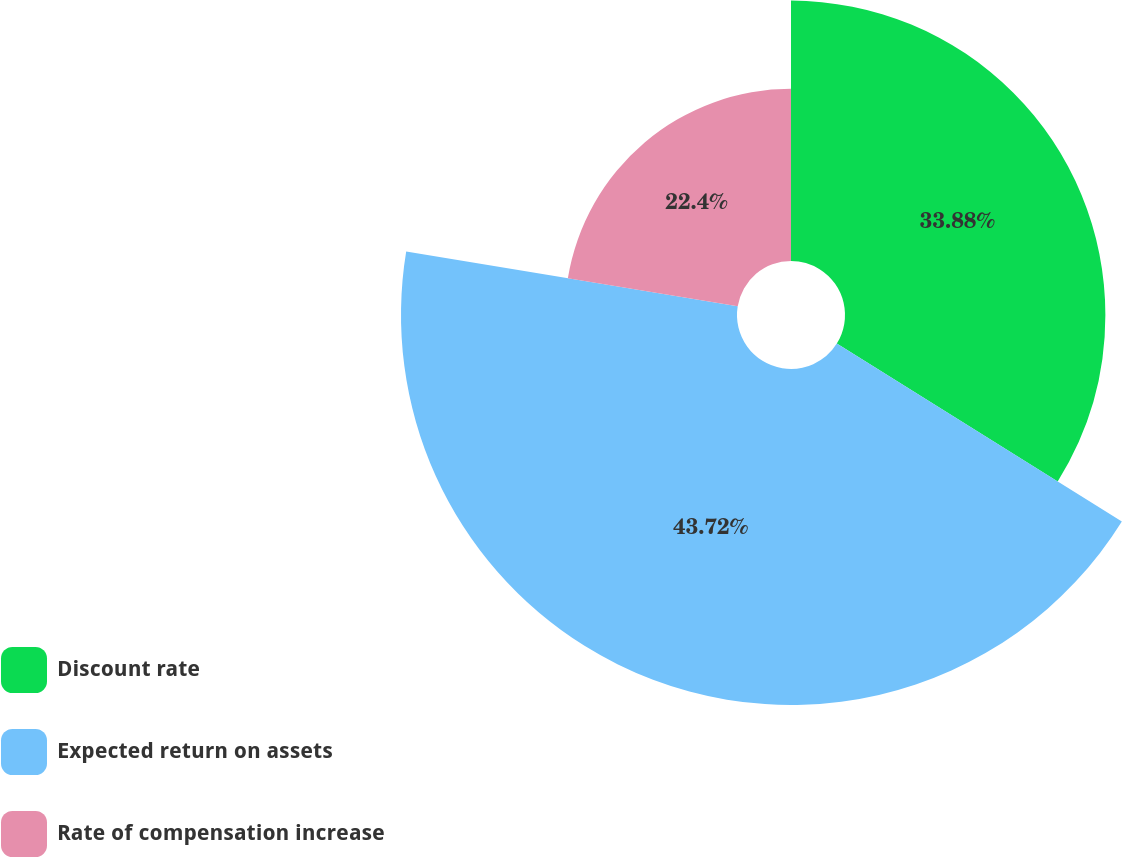<chart> <loc_0><loc_0><loc_500><loc_500><pie_chart><fcel>Discount rate<fcel>Expected return on assets<fcel>Rate of compensation increase<nl><fcel>33.88%<fcel>43.72%<fcel>22.4%<nl></chart> 